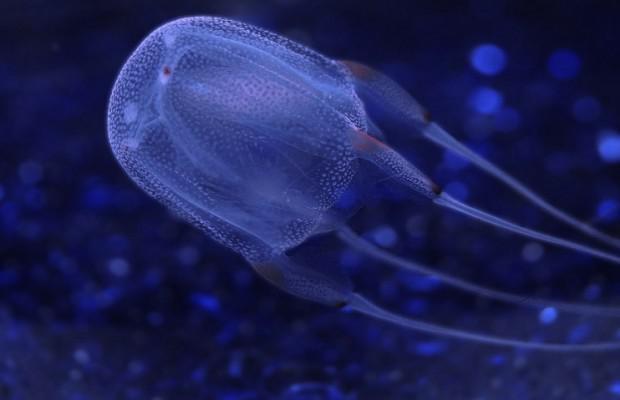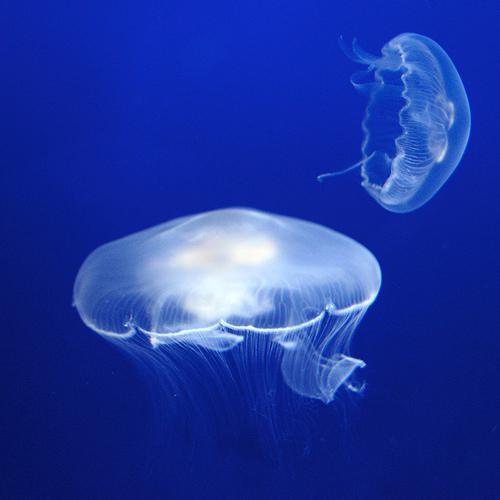The first image is the image on the left, the second image is the image on the right. Considering the images on both sides, is "The left image contains at least three jelly fish." valid? Answer yes or no. No. The first image is the image on the left, the second image is the image on the right. Given the left and right images, does the statement "An image includes a jellyfish with long thread-like tendrils extending backward, to the right." hold true? Answer yes or no. Yes. 